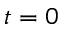Convert formula to latex. <formula><loc_0><loc_0><loc_500><loc_500>t = 0</formula> 